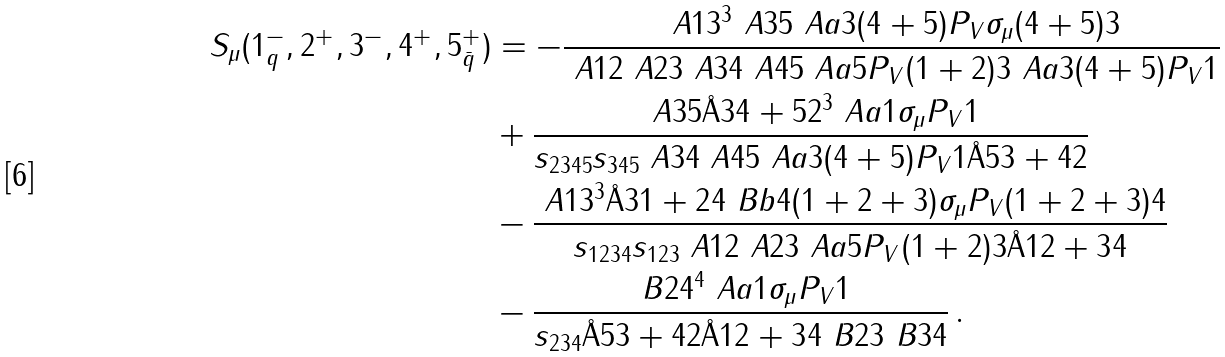<formula> <loc_0><loc_0><loc_500><loc_500>S _ { \mu } ( 1 _ { q } ^ { - } , 2 ^ { + } , 3 ^ { - } , 4 ^ { + } , 5 _ { \bar { q } } ^ { + } ) & = - \frac { \ A { 1 } { 3 } ^ { 3 } \ A { 3 } { 5 } \ A a { 3 } { ( 4 + 5 ) P _ { V } \sigma _ { \mu } ( 4 + 5 ) } { 3 } } { \ A { 1 } { 2 } \ A { 2 } { 3 } \ A { 3 } { 4 } \ A { 4 } { 5 } \ A a { 5 } { P _ { V } ( 1 + 2 ) } { 3 } \ A a { 3 } { ( 4 + 5 ) P _ { V } } { 1 } } \\ & + \frac { \ A { 3 } { 5 } \AA { 3 } { 4 + 5 } { 2 } ^ { 3 } \ A a { 1 } { \sigma _ { \mu } P _ { V } } { 1 } } { s _ { 2 3 4 5 } s _ { 3 4 5 } \ A { 3 } { 4 } \ A { 4 } { 5 } \ A a { 3 } { ( 4 + 5 ) P _ { V } } { 1 } \AA { 5 } { 3 + 4 } { 2 } } \\ & - \frac { \ A { 1 } { 3 } ^ { 3 } \AA { 3 } { 1 + 2 } { 4 } \ B b { 4 } { ( 1 + 2 + 3 ) \sigma _ { \mu } P _ { V } ( 1 + 2 + 3 ) } { 4 } } { s _ { 1 2 3 4 } s _ { 1 2 3 } \ A { 1 } { 2 } \ A { 2 } { 3 } \ A a { 5 } { P _ { V } ( 1 + 2 ) } { 3 } \AA { 1 } { 2 + 3 } { 4 } } \\ & - \frac { \ B { 2 } { 4 } ^ { 4 } \ A a { 1 } { \sigma _ { \mu } P _ { V } } { 1 } } { s _ { 2 3 4 } \AA { 5 } { 3 + 4 } { 2 } \AA { 1 } { 2 + 3 } { 4 } \ B { 2 } { 3 } \ B { 3 } { 4 } } \, .</formula> 